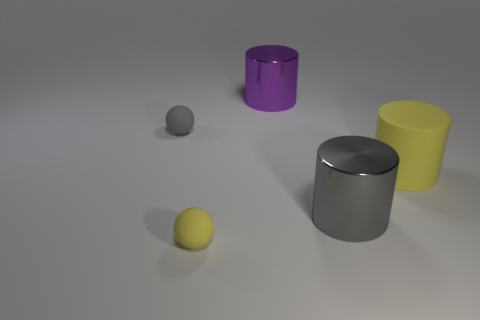Add 3 large purple metal cylinders. How many objects exist? 8 Subtract all cylinders. How many objects are left? 2 Add 4 small green matte objects. How many small green matte objects exist? 4 Subtract 1 purple cylinders. How many objects are left? 4 Subtract all small rubber cylinders. Subtract all small yellow things. How many objects are left? 4 Add 4 large yellow objects. How many large yellow objects are left? 5 